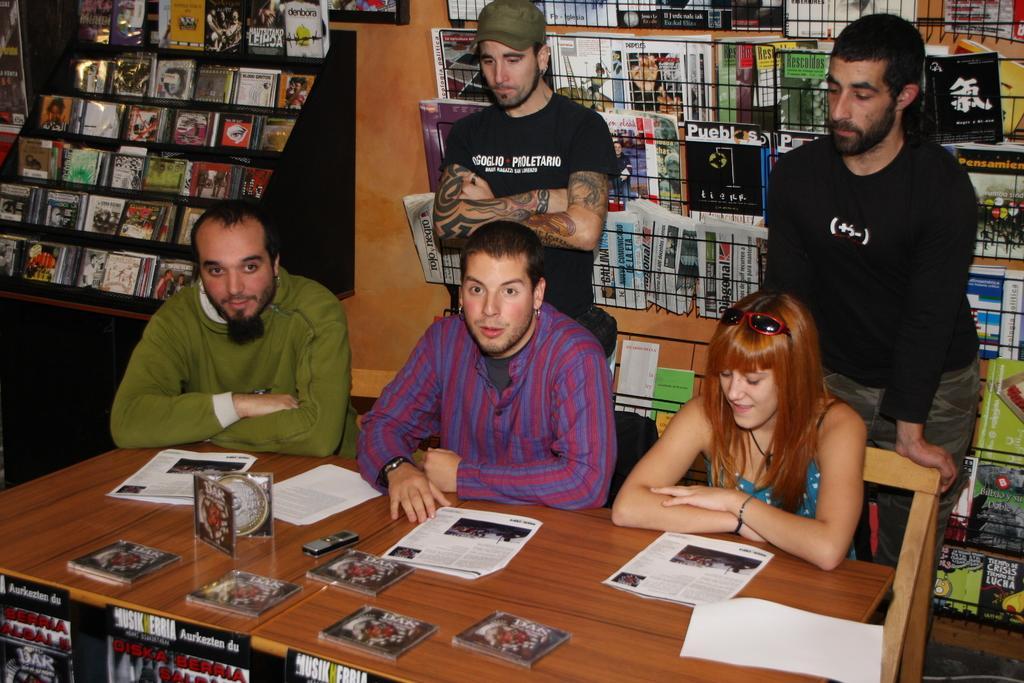Describe this image in one or two sentences. In this image we can see persons of them some are sitting on the chairs and some are standing behind them. Before the persons a table is placed and on that papers, clock and crochets are present. Behind the persons we can see books arranged in rows. 